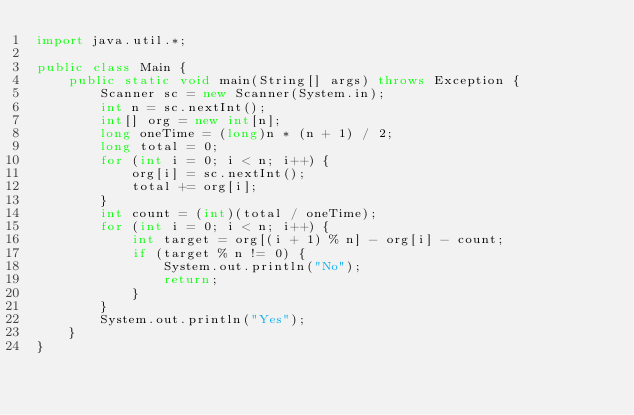Convert code to text. <code><loc_0><loc_0><loc_500><loc_500><_Java_>import java.util.*;

public class Main {
    public static void main(String[] args) throws Exception {
        Scanner sc = new Scanner(System.in);
        int n = sc.nextInt();
        int[] org = new int[n];
        long oneTime = (long)n * (n + 1) / 2;
        long total = 0;
        for (int i = 0; i < n; i++) {
            org[i] = sc.nextInt();
            total += org[i];
        }
        int count = (int)(total / oneTime);
        for (int i = 0; i < n; i++) {
            int target = org[(i + 1) % n] - org[i] - count;
            if (target % n != 0) {
                System.out.println("No");
                return;
            }
        }
        System.out.println("Yes");
    }
}
</code> 